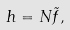<formula> <loc_0><loc_0><loc_500><loc_500>h = N \tilde { f } ,</formula> 